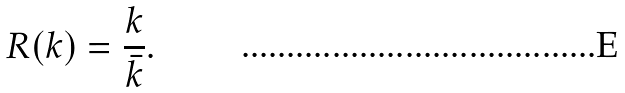Convert formula to latex. <formula><loc_0><loc_0><loc_500><loc_500>R ( k ) = \frac { k } { \bar { k } } .</formula> 